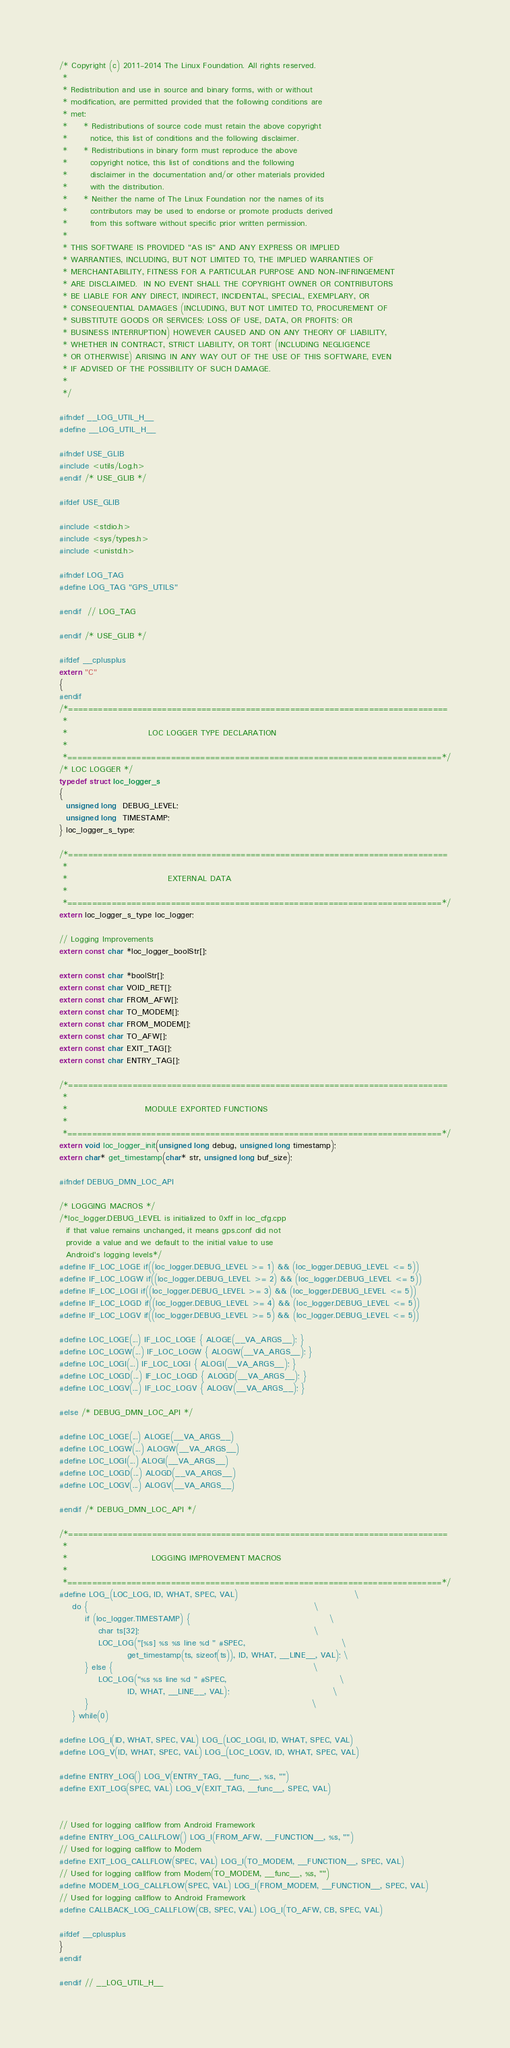Convert code to text. <code><loc_0><loc_0><loc_500><loc_500><_C_>/* Copyright (c) 2011-2014 The Linux Foundation. All rights reserved.
 *
 * Redistribution and use in source and binary forms, with or without
 * modification, are permitted provided that the following conditions are
 * met:
 *     * Redistributions of source code must retain the above copyright
 *       notice, this list of conditions and the following disclaimer.
 *     * Redistributions in binary form must reproduce the above
 *       copyright notice, this list of conditions and the following
 *       disclaimer in the documentation and/or other materials provided
 *       with the distribution.
 *     * Neither the name of The Linux Foundation nor the names of its
 *       contributors may be used to endorse or promote products derived
 *       from this software without specific prior written permission.
 *
 * THIS SOFTWARE IS PROVIDED "AS IS" AND ANY EXPRESS OR IMPLIED
 * WARRANTIES, INCLUDING, BUT NOT LIMITED TO, THE IMPLIED WARRANTIES OF
 * MERCHANTABILITY, FITNESS FOR A PARTICULAR PURPOSE AND NON-INFRINGEMENT
 * ARE DISCLAIMED.  IN NO EVENT SHALL THE COPYRIGHT OWNER OR CONTRIBUTORS
 * BE LIABLE FOR ANY DIRECT, INDIRECT, INCIDENTAL, SPECIAL, EXEMPLARY, OR
 * CONSEQUENTIAL DAMAGES (INCLUDING, BUT NOT LIMITED TO, PROCUREMENT OF
 * SUBSTITUTE GOODS OR SERVICES; LOSS OF USE, DATA, OR PROFITS; OR
 * BUSINESS INTERRUPTION) HOWEVER CAUSED AND ON ANY THEORY OF LIABILITY,
 * WHETHER IN CONTRACT, STRICT LIABILITY, OR TORT (INCLUDING NEGLIGENCE
 * OR OTHERWISE) ARISING IN ANY WAY OUT OF THE USE OF THIS SOFTWARE, EVEN
 * IF ADVISED OF THE POSSIBILITY OF SUCH DAMAGE.
 *
 */

#ifndef __LOG_UTIL_H__
#define __LOG_UTIL_H__

#ifndef USE_GLIB
#include <utils/Log.h>
#endif /* USE_GLIB */

#ifdef USE_GLIB

#include <stdio.h>
#include <sys/types.h>
#include <unistd.h>

#ifndef LOG_TAG
#define LOG_TAG "GPS_UTILS"

#endif  // LOG_TAG

#endif /* USE_GLIB */

#ifdef __cplusplus
extern "C"
{
#endif
/*=============================================================================
 *
 *                         LOC LOGGER TYPE DECLARATION
 *
 *============================================================================*/
/* LOC LOGGER */
typedef struct loc_logger_s
{
  unsigned long  DEBUG_LEVEL;
  unsigned long  TIMESTAMP;
} loc_logger_s_type;

/*=============================================================================
 *
 *                               EXTERNAL DATA
 *
 *============================================================================*/
extern loc_logger_s_type loc_logger;

// Logging Improvements
extern const char *loc_logger_boolStr[];

extern const char *boolStr[];
extern const char VOID_RET[];
extern const char FROM_AFW[];
extern const char TO_MODEM[];
extern const char FROM_MODEM[];
extern const char TO_AFW[];
extern const char EXIT_TAG[];
extern const char ENTRY_TAG[];

/*=============================================================================
 *
 *                        MODULE EXPORTED FUNCTIONS
 *
 *============================================================================*/
extern void loc_logger_init(unsigned long debug, unsigned long timestamp);
extern char* get_timestamp(char* str, unsigned long buf_size);

#ifndef DEBUG_DMN_LOC_API

/* LOGGING MACROS */
/*loc_logger.DEBUG_LEVEL is initialized to 0xff in loc_cfg.cpp
  if that value remains unchanged, it means gps.conf did not
  provide a value and we default to the initial value to use
  Android's logging levels*/
#define IF_LOC_LOGE if((loc_logger.DEBUG_LEVEL >= 1) && (loc_logger.DEBUG_LEVEL <= 5))
#define IF_LOC_LOGW if((loc_logger.DEBUG_LEVEL >= 2) && (loc_logger.DEBUG_LEVEL <= 5))
#define IF_LOC_LOGI if((loc_logger.DEBUG_LEVEL >= 3) && (loc_logger.DEBUG_LEVEL <= 5))
#define IF_LOC_LOGD if((loc_logger.DEBUG_LEVEL >= 4) && (loc_logger.DEBUG_LEVEL <= 5))
#define IF_LOC_LOGV if((loc_logger.DEBUG_LEVEL >= 5) && (loc_logger.DEBUG_LEVEL <= 5))

#define LOC_LOGE(...) IF_LOC_LOGE { ALOGE(__VA_ARGS__); }
#define LOC_LOGW(...) IF_LOC_LOGW { ALOGW(__VA_ARGS__); }
#define LOC_LOGI(...) IF_LOC_LOGI { ALOGI(__VA_ARGS__); }
#define LOC_LOGD(...) IF_LOC_LOGD { ALOGD(__VA_ARGS__); }
#define LOC_LOGV(...) IF_LOC_LOGV { ALOGV(__VA_ARGS__); }

#else /* DEBUG_DMN_LOC_API */

#define LOC_LOGE(...) ALOGE(__VA_ARGS__)
#define LOC_LOGW(...) ALOGW(__VA_ARGS__)
#define LOC_LOGI(...) ALOGI(__VA_ARGS__)
#define LOC_LOGD(...) ALOGD(__VA_ARGS__)
#define LOC_LOGV(...) ALOGV(__VA_ARGS__)

#endif /* DEBUG_DMN_LOC_API */

/*=============================================================================
 *
 *                          LOGGING IMPROVEMENT MACROS
 *
 *============================================================================*/
#define LOG_(LOC_LOG, ID, WHAT, SPEC, VAL)                                    \
    do {                                                                      \
        if (loc_logger.TIMESTAMP) {                                           \
            char ts[32];                                                      \
            LOC_LOG("[%s] %s %s line %d " #SPEC,                              \
                     get_timestamp(ts, sizeof(ts)), ID, WHAT, __LINE__, VAL); \
        } else {                                                              \
            LOC_LOG("%s %s line %d " #SPEC,                                   \
                     ID, WHAT, __LINE__, VAL);                                \
        }                                                                     \
    } while(0)

#define LOG_I(ID, WHAT, SPEC, VAL) LOG_(LOC_LOGI, ID, WHAT, SPEC, VAL)
#define LOG_V(ID, WHAT, SPEC, VAL) LOG_(LOC_LOGV, ID, WHAT, SPEC, VAL)

#define ENTRY_LOG() LOG_V(ENTRY_TAG, __func__, %s, "")
#define EXIT_LOG(SPEC, VAL) LOG_V(EXIT_TAG, __func__, SPEC, VAL)


// Used for logging callflow from Android Framework
#define ENTRY_LOG_CALLFLOW() LOG_I(FROM_AFW, __FUNCTION__, %s, "")
// Used for logging callflow to Modem
#define EXIT_LOG_CALLFLOW(SPEC, VAL) LOG_I(TO_MODEM, __FUNCTION__, SPEC, VAL)
// Used for logging callflow from Modem(TO_MODEM, __func__, %s, "")
#define MODEM_LOG_CALLFLOW(SPEC, VAL) LOG_I(FROM_MODEM, __FUNCTION__, SPEC, VAL)
// Used for logging callflow to Android Framework
#define CALLBACK_LOG_CALLFLOW(CB, SPEC, VAL) LOG_I(TO_AFW, CB, SPEC, VAL)

#ifdef __cplusplus
}
#endif

#endif // __LOG_UTIL_H__
</code> 